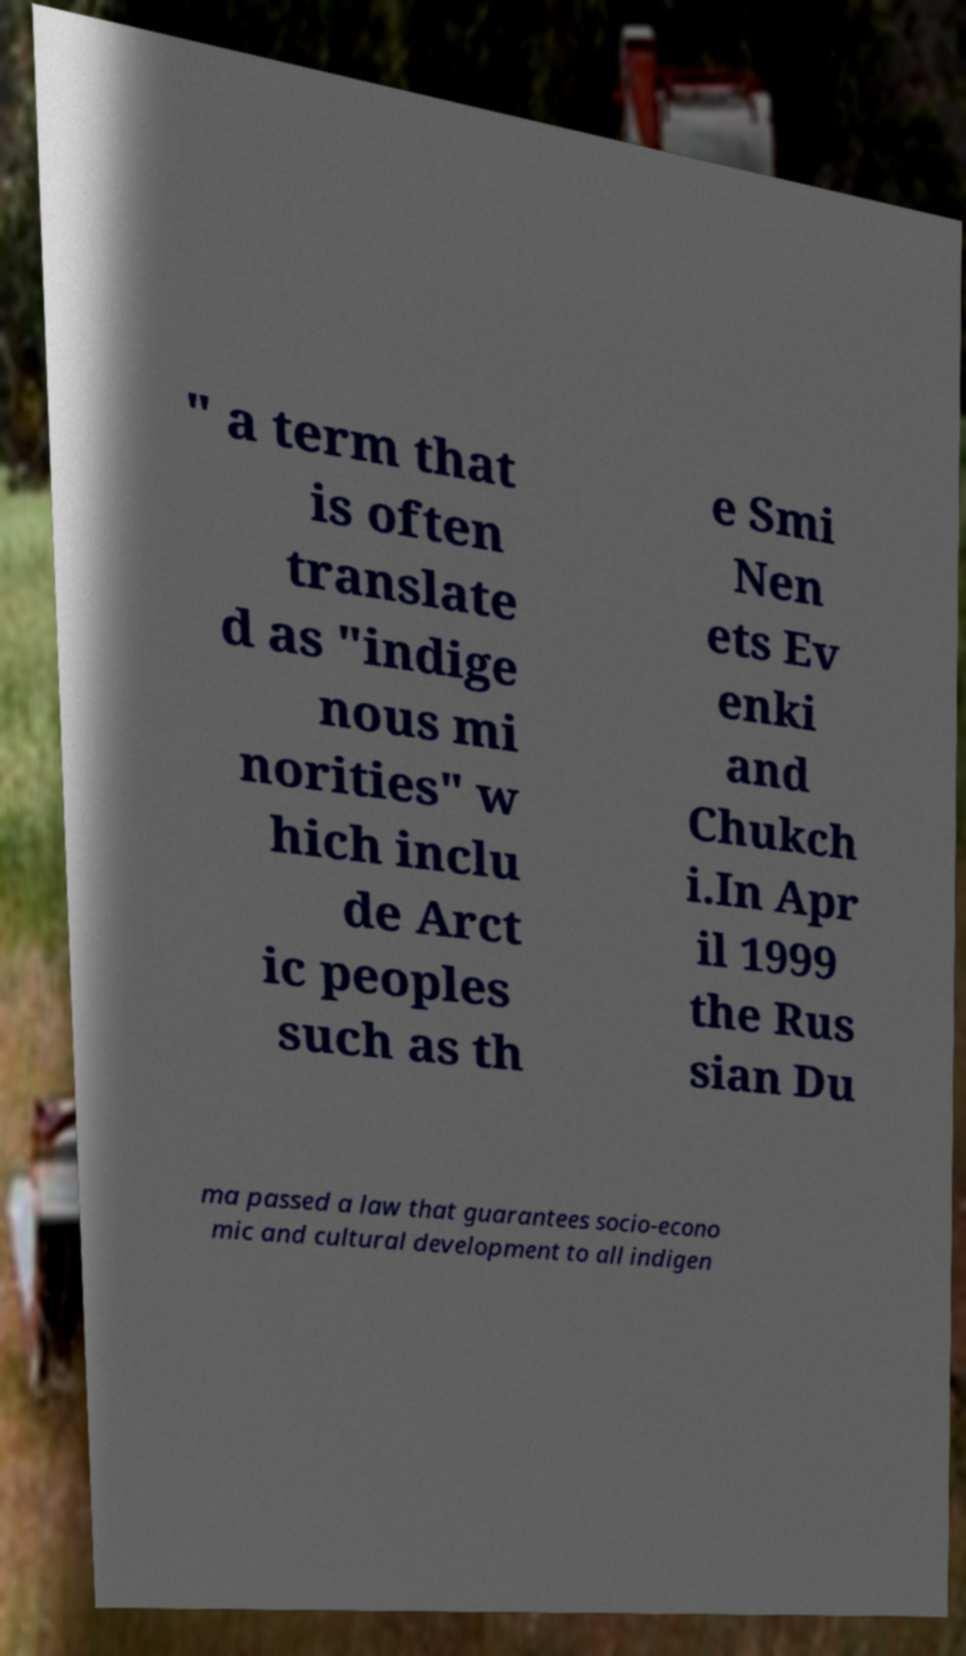Can you accurately transcribe the text from the provided image for me? " a term that is often translate d as "indige nous mi norities" w hich inclu de Arct ic peoples such as th e Smi Nen ets Ev enki and Chukch i.In Apr il 1999 the Rus sian Du ma passed a law that guarantees socio-econo mic and cultural development to all indigen 